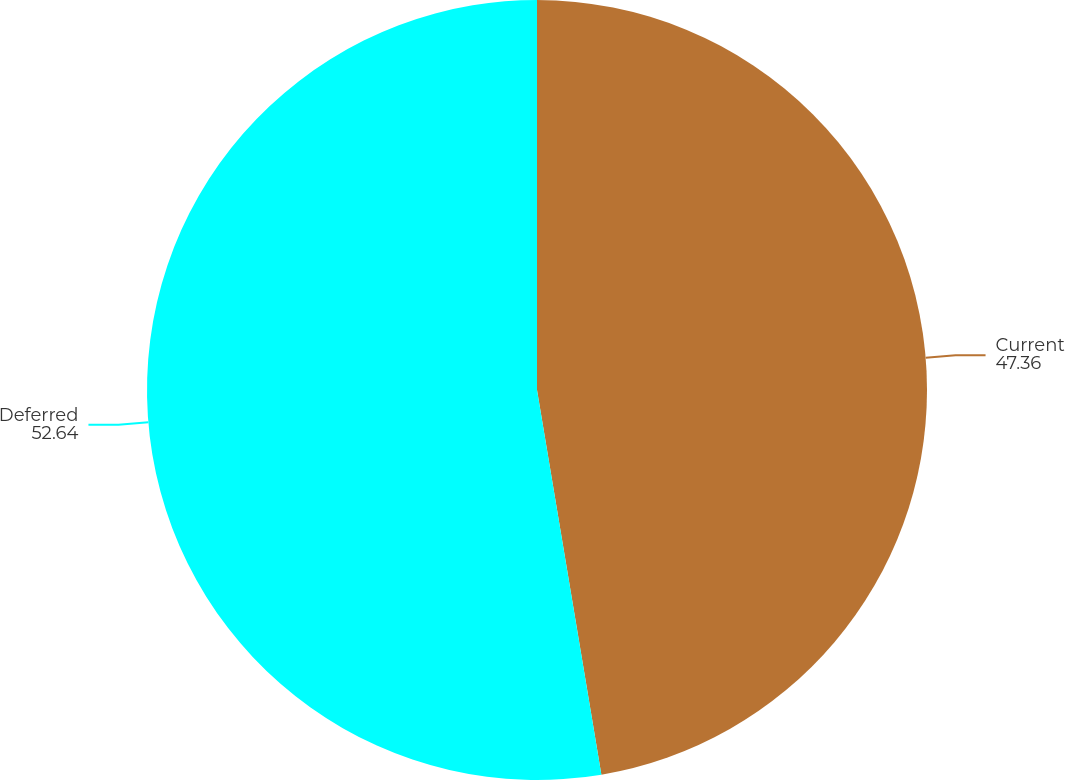<chart> <loc_0><loc_0><loc_500><loc_500><pie_chart><fcel>Current<fcel>Deferred<nl><fcel>47.36%<fcel>52.64%<nl></chart> 